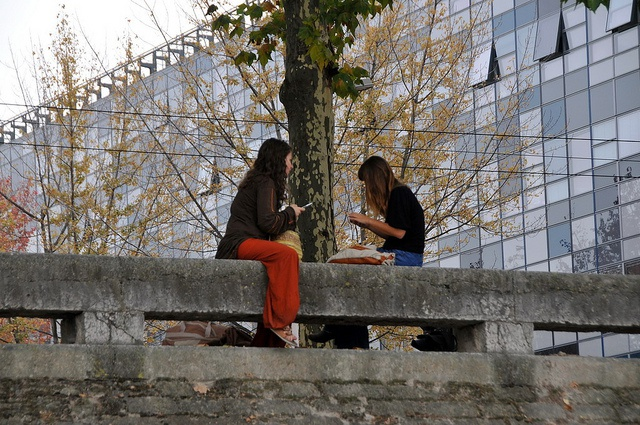Describe the objects in this image and their specific colors. I can see people in white, black, maroon, and gray tones, people in white, black, maroon, and navy tones, handbag in white, gray, maroon, and black tones, handbag in white, darkgray, maroon, and gray tones, and handbag in white, gray, tan, brown, and olive tones in this image. 